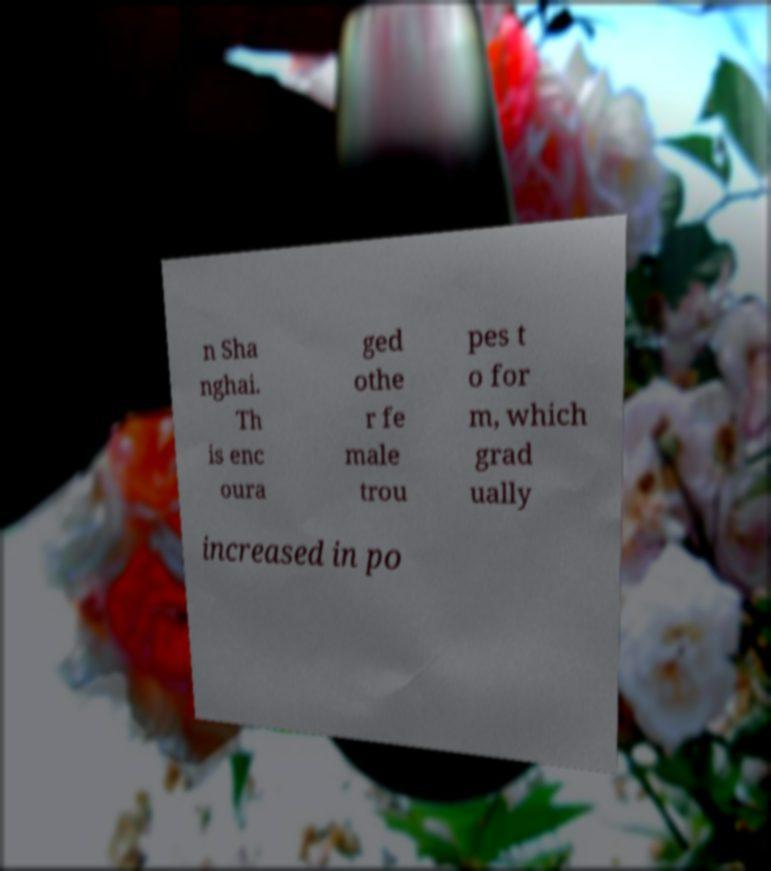There's text embedded in this image that I need extracted. Can you transcribe it verbatim? n Sha nghai. Th is enc oura ged othe r fe male trou pes t o for m, which grad ually increased in po 